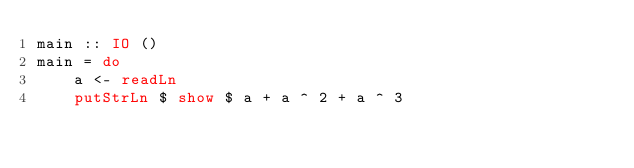<code> <loc_0><loc_0><loc_500><loc_500><_Haskell_>main :: IO ()
main = do
    a <- readLn 
    putStrLn $ show $ a + a ^ 2 + a ^ 3</code> 